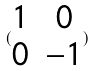Convert formula to latex. <formula><loc_0><loc_0><loc_500><loc_500>( \begin{matrix} 1 & 0 \\ 0 & - 1 \end{matrix} )</formula> 